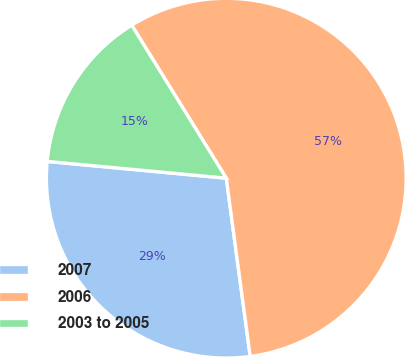<chart> <loc_0><loc_0><loc_500><loc_500><pie_chart><fcel>2007<fcel>2006<fcel>2003 to 2005<nl><fcel>28.61%<fcel>56.69%<fcel>14.7%<nl></chart> 